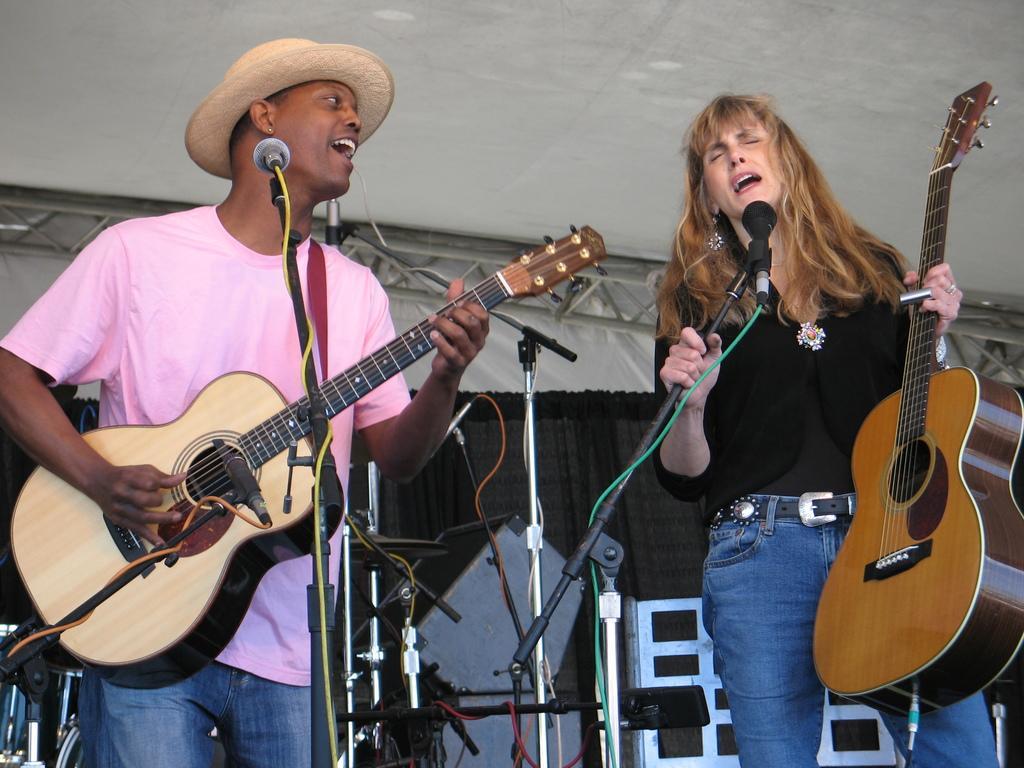Describe this image in one or two sentences. In this picture there is a boy who is standing at the left side of the image and he is playing the guitar, there is a girl at the right side of the image, she is holding a guitar in her hand and she is singing in the mic, there is a black color curtain behind them. 